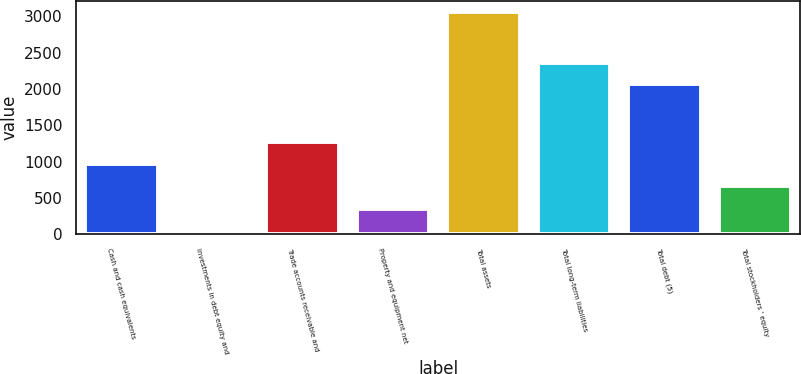Convert chart to OTSL. <chart><loc_0><loc_0><loc_500><loc_500><bar_chart><fcel>Cash and cash equivalents<fcel>Investments in debt equity and<fcel>Trade accounts receivable and<fcel>Property and equipment net<fcel>Total assets<fcel>Total long-term liabilities<fcel>Total debt (5)<fcel>Total stockholders ' equity<nl><fcel>968.4<fcel>40<fcel>1269.8<fcel>341.4<fcel>3054<fcel>2362.4<fcel>2061<fcel>667<nl></chart> 